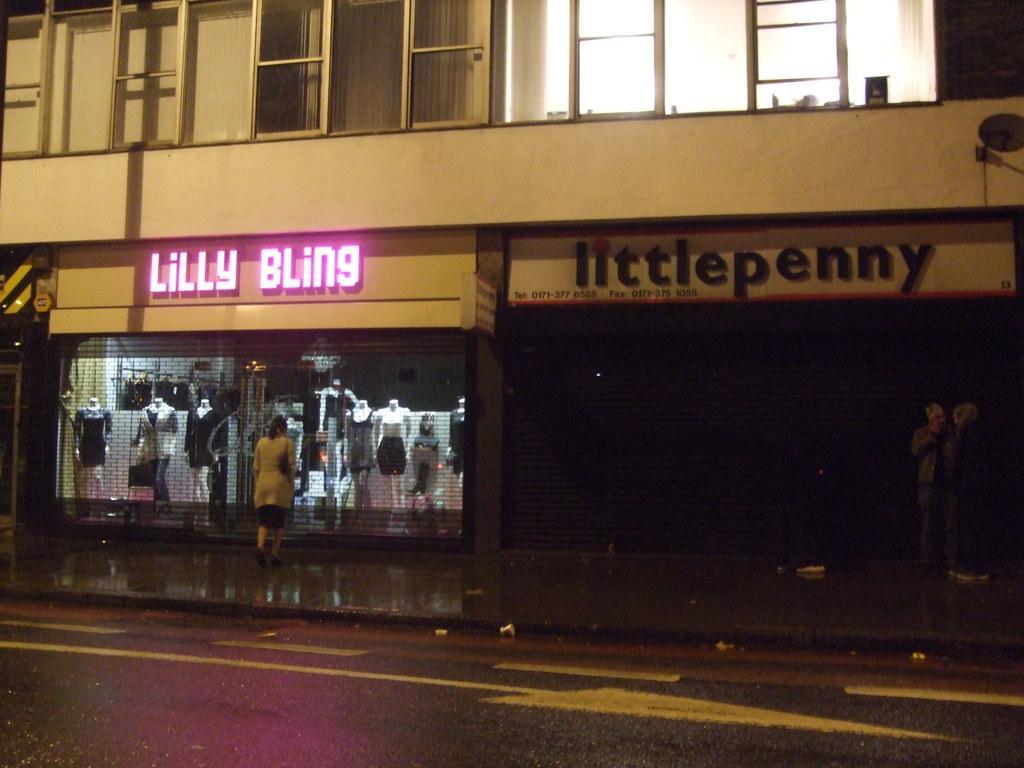How would you summarize this image in a sentence or two? In this image in front there is a road. On the backside of the image there is a building with the glass windows. In front of the building there are two persons standing on the pavement. 